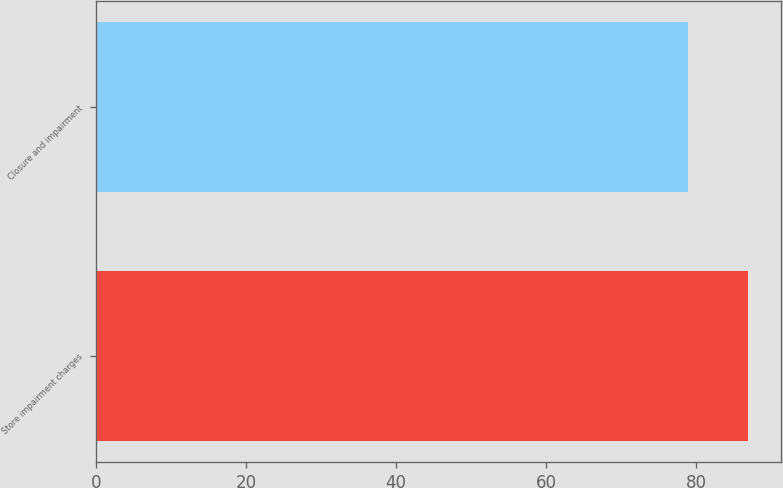Convert chart to OTSL. <chart><loc_0><loc_0><loc_500><loc_500><bar_chart><fcel>Store impairment charges<fcel>Closure and impairment<nl><fcel>87<fcel>79<nl></chart> 